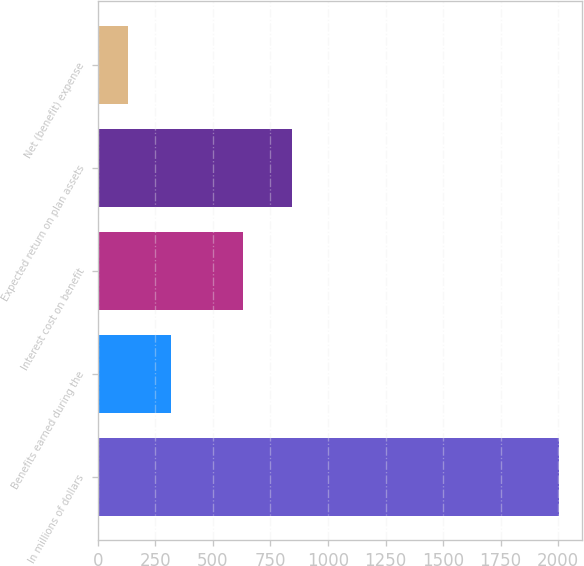Convert chart. <chart><loc_0><loc_0><loc_500><loc_500><bar_chart><fcel>In millions of dollars<fcel>Benefits earned during the<fcel>Interest cost on benefit<fcel>Expected return on plan assets<fcel>Net (benefit) expense<nl><fcel>2006<fcel>318.5<fcel>630<fcel>845<fcel>131<nl></chart> 